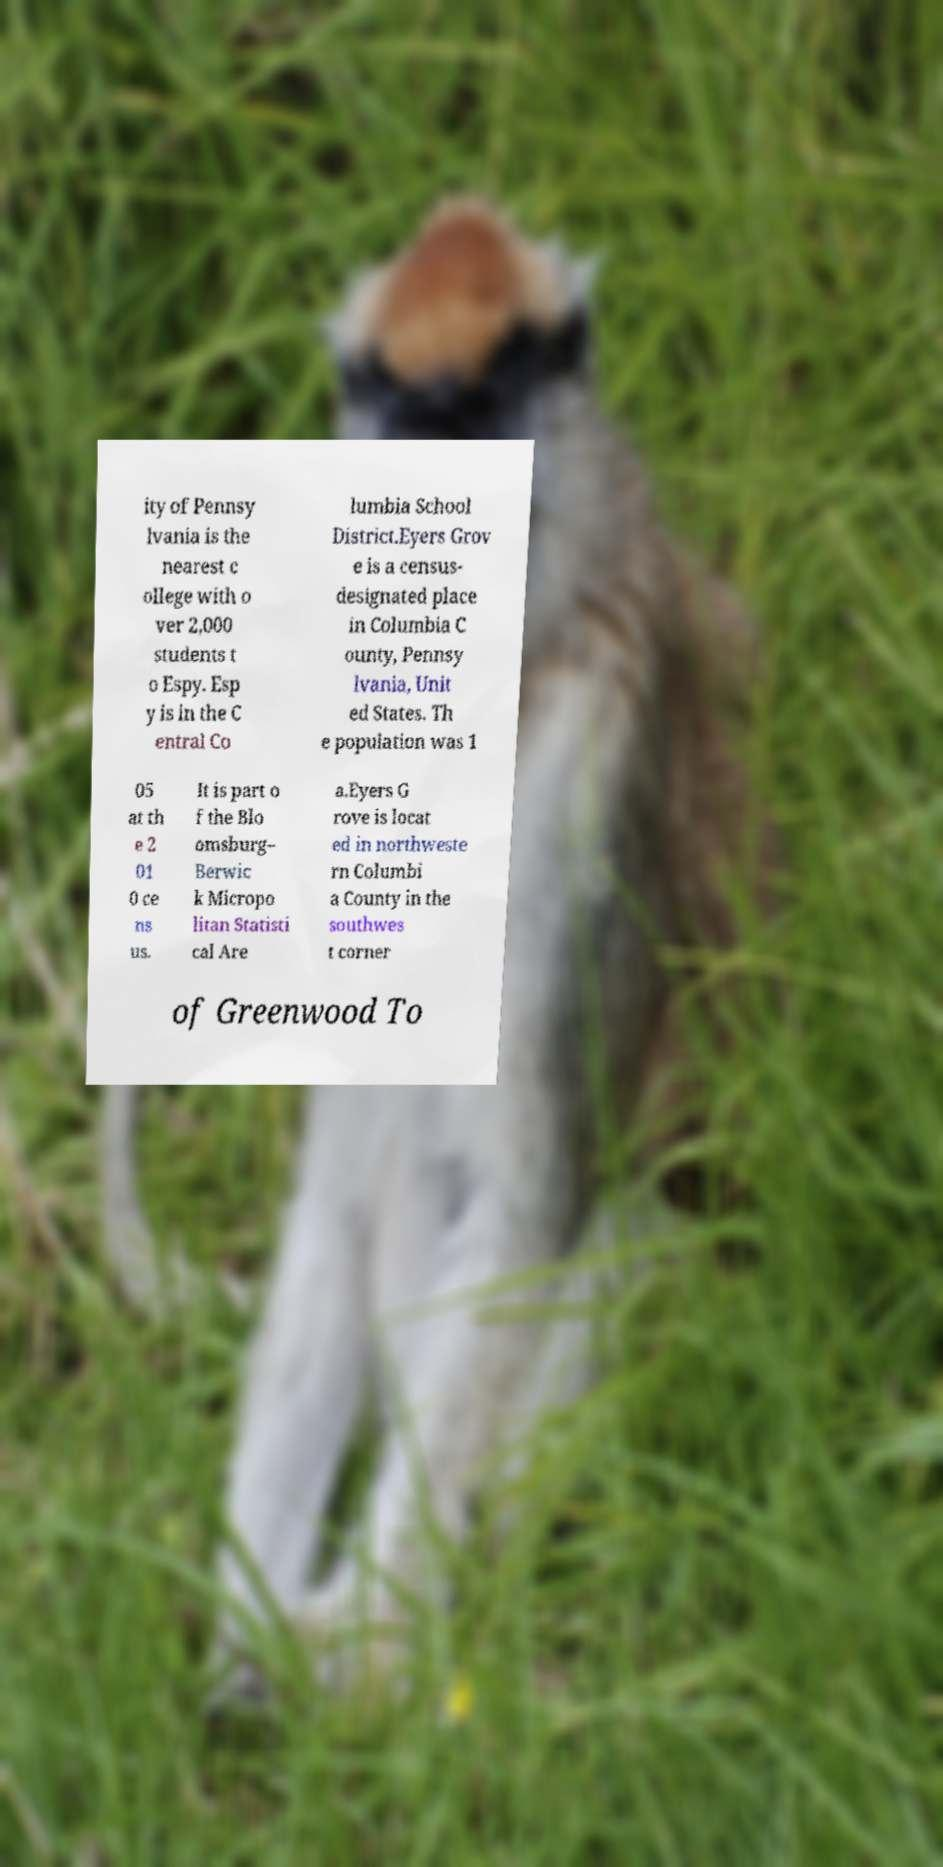What messages or text are displayed in this image? I need them in a readable, typed format. ity of Pennsy lvania is the nearest c ollege with o ver 2,000 students t o Espy. Esp y is in the C entral Co lumbia School District.Eyers Grov e is a census- designated place in Columbia C ounty, Pennsy lvania, Unit ed States. Th e population was 1 05 at th e 2 01 0 ce ns us. It is part o f the Blo omsburg– Berwic k Micropo litan Statisti cal Are a.Eyers G rove is locat ed in northweste rn Columbi a County in the southwes t corner of Greenwood To 